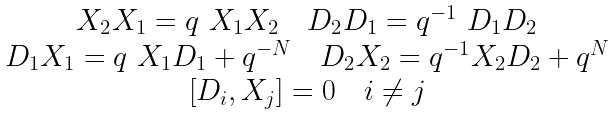Convert formula to latex. <formula><loc_0><loc_0><loc_500><loc_500>\begin{array} { c } X _ { 2 } X _ { 1 } = q \ X _ { 1 } X _ { 2 } \quad D _ { 2 } D _ { 1 } = q ^ { - 1 } \ D _ { 1 } D _ { 2 } \\ D _ { 1 } X _ { 1 } = q \ X _ { 1 } D _ { 1 } + q ^ { - N } \quad D _ { 2 } X _ { 2 } = q ^ { - 1 } X _ { 2 } D _ { 2 } + q ^ { N } \\ \left [ D _ { i } , X _ { j } \right ] = 0 \quad i \neq j \end{array}</formula> 